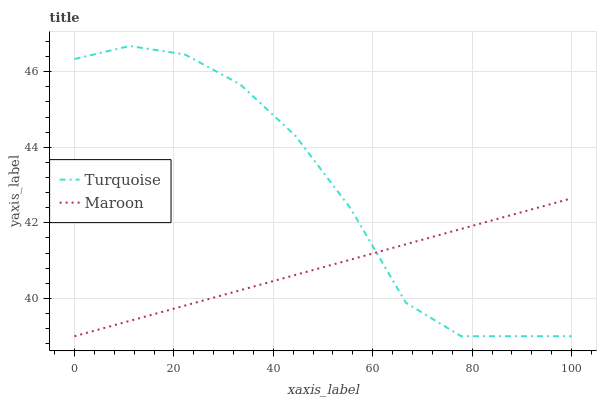Does Maroon have the minimum area under the curve?
Answer yes or no. Yes. Does Turquoise have the maximum area under the curve?
Answer yes or no. Yes. Does Maroon have the maximum area under the curve?
Answer yes or no. No. Is Maroon the smoothest?
Answer yes or no. Yes. Is Turquoise the roughest?
Answer yes or no. Yes. Is Maroon the roughest?
Answer yes or no. No. Does Turquoise have the highest value?
Answer yes or no. Yes. Does Maroon have the highest value?
Answer yes or no. No. Does Maroon intersect Turquoise?
Answer yes or no. Yes. Is Maroon less than Turquoise?
Answer yes or no. No. Is Maroon greater than Turquoise?
Answer yes or no. No. 